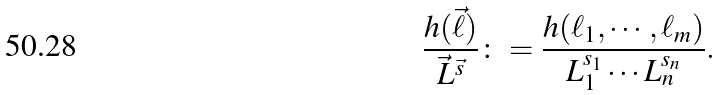Convert formula to latex. <formula><loc_0><loc_0><loc_500><loc_500>\frac { h ( \vec { \ell } ) } { \vec { L } ^ { \vec { s } } } \colon = \frac { h ( \ell _ { 1 } , \cdots , \ell _ { m } ) } { L _ { 1 } ^ { s _ { 1 } } \cdots L _ { n } ^ { s _ { n } } } .</formula> 